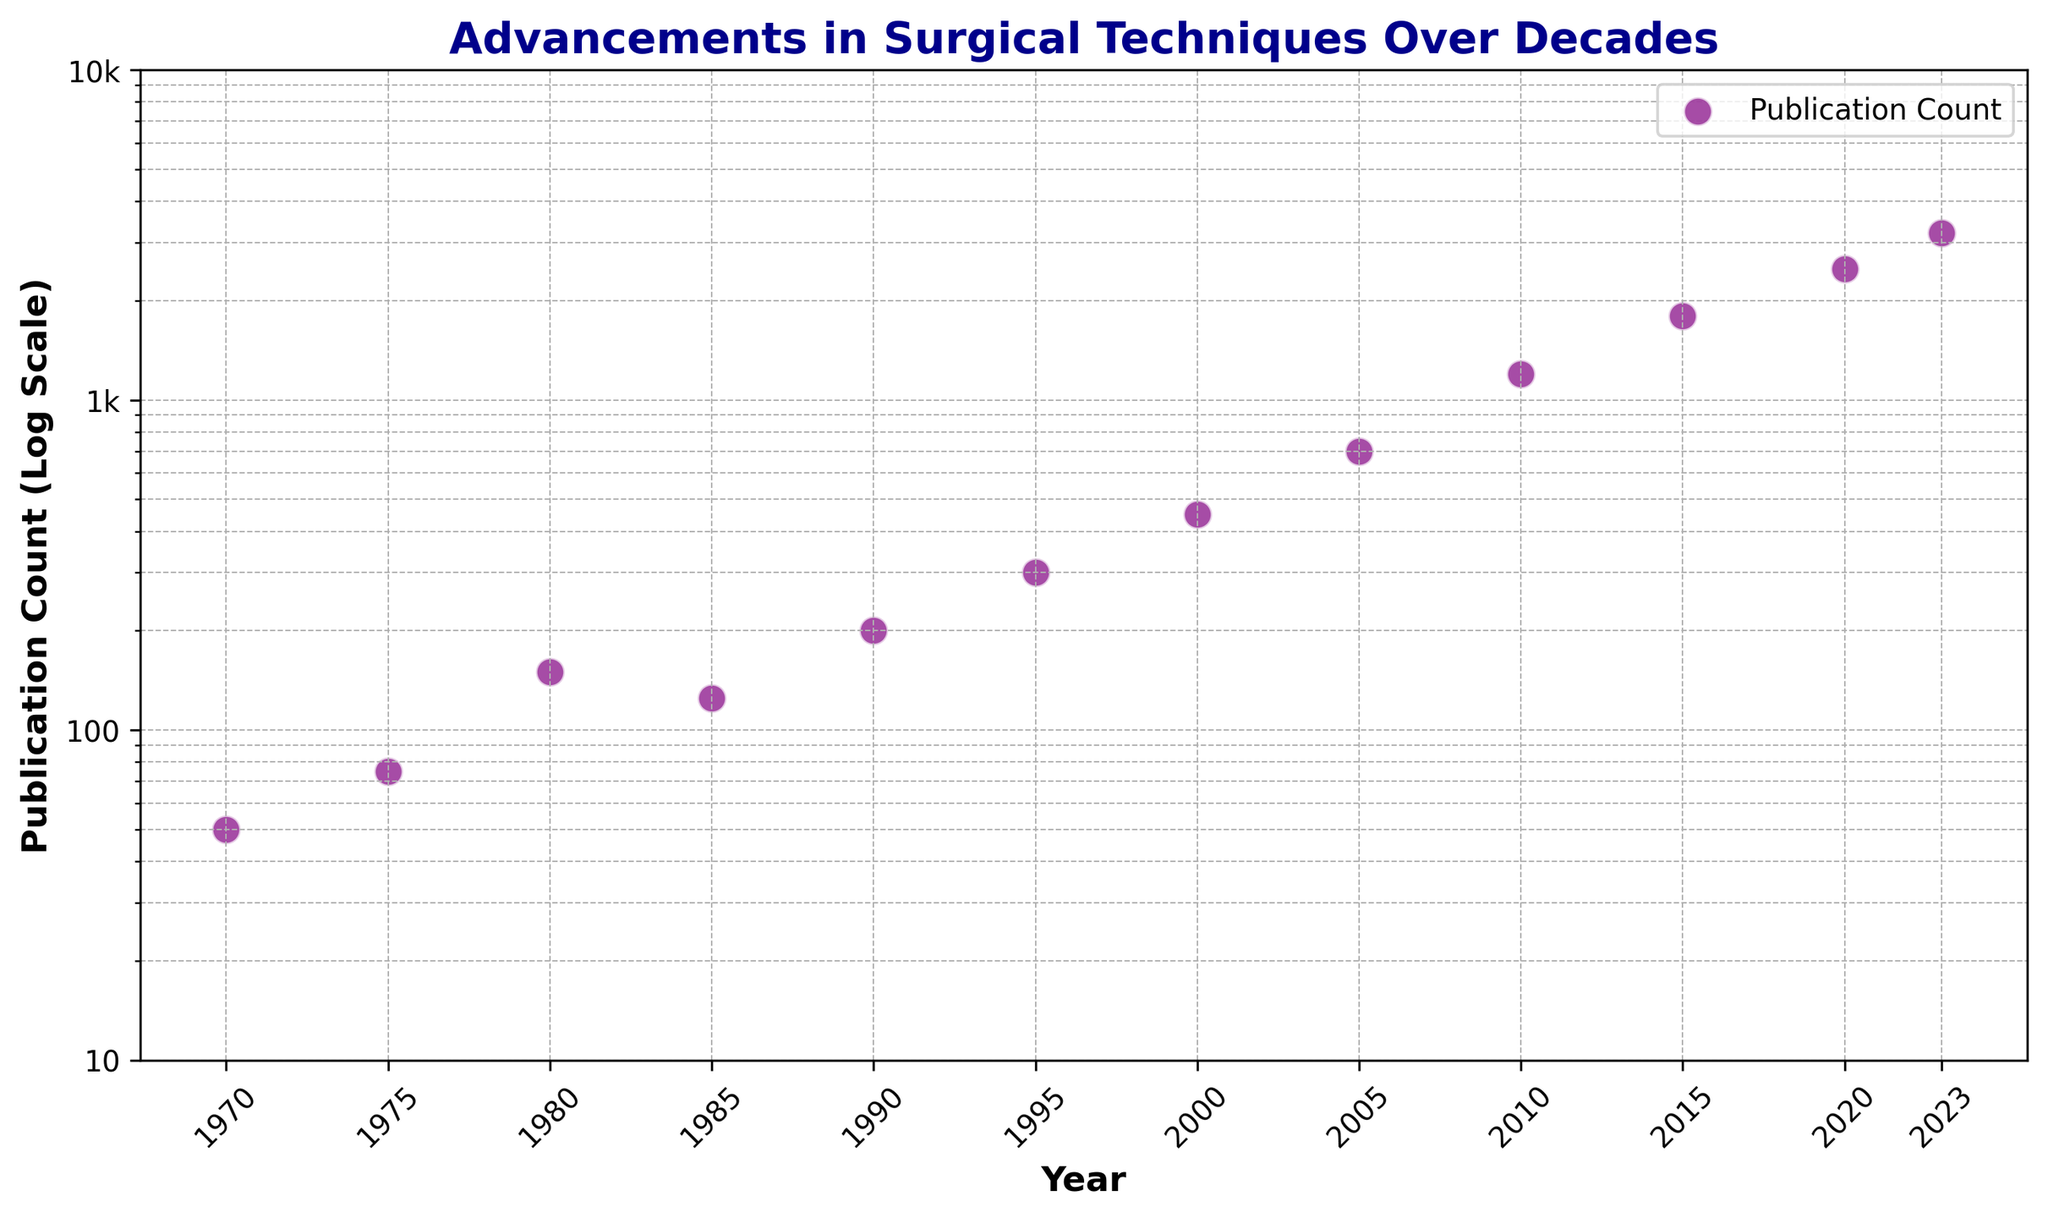What is the highest publication count observed on the chart? The highest publication count can be seen at the topmost point on the plot. It occurs in the year 2023, with a publication count of 3200.
Answer: 3200 How many decades are covered in the plot? The plot starts with the year 1970 and ends with the year 2023. Count the number of full decades: 1970-1979, 1980-1989, 1990-1999, 2000-2009, 2010-2019, and partially through the 2020s. There are 5 full decades and part of the 2020s.
Answer: 6 In which decade did publication count increase the most? To determine the decade with the largest increase, calculate the differences between the publication counts at the start and end of each decade: 
1. 1970s: 75 - 50 = 25 
2. 1980s: 150 - 75 = 75 
3. 1990s: 300 - 125 = 175 
4. 2000s: 700 - 450 = 250 
5. 2010s: 1800 - 1200 = 600 
The largest increase occurs in the 2010s.
Answer: 2010s What is the range of publication counts shown on the y-axis? The publication counts on the y-axis range from approximately 10 to 10,000 (labeled as '10', '100', '1k', '10k').
Answer: 10 to 10,000 Which year experienced the smallest publication count, and what was it? The smallest publication count is observed at the beginning of the timeline, in the year 1970, with a count of 50.
Answer: 1970, 50 Identify the two years with publication counts closest to each other and provide their counts. Comparing each pair of adjacent years, the years 1980 and 1985 have relatively close publication counts: 150 and 125. The difference between 150 and 125 is only 25.
Answer: 1980 (150) and 1985 (125) What is the median publication count over the plotted years? First, list the publication counts in ascending order: 50, 75, 125, 150, 200, 300, 450, 700, 1200, 1800, 2500, 3200. The median is the average of the two middle numbers (450 and 700) since there are 12 data points. Median = (450 + 700) / 2 = 575.
Answer: 575 How does the publication count in 2000 compare to that in 1990? The publication count in 2000 is 450, whereas for 1990, it is 200. To compare, 450 (2000) is significantly greater than 200 (1990).
Answer: 2000 has greater count Between which successive years was the publication count's relative change the largest? To find the largest relative change, compute the relative change for each pair of successive years and compare. Observe the regions where the exponential logscale change is largest:
1. 2000 to 2005: (700 - 450) / 450 = 0.5556
2. 2005 to 2010: (1200 - 700) / 700 = 0.7143
Comparing relative changes, the largest occurs from 2005 to 2010.
Answer: 2005 to 2010 